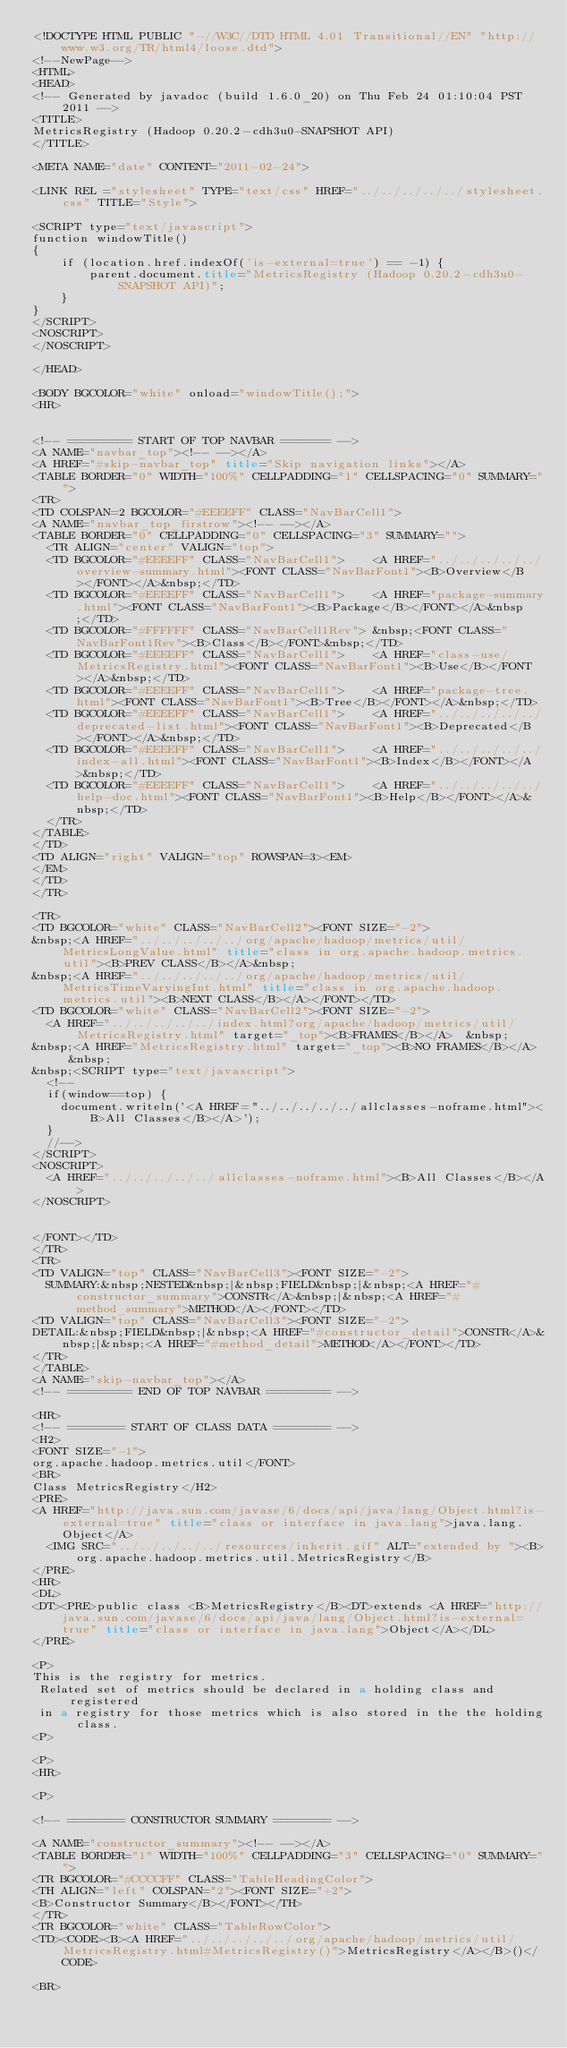<code> <loc_0><loc_0><loc_500><loc_500><_HTML_><!DOCTYPE HTML PUBLIC "-//W3C//DTD HTML 4.01 Transitional//EN" "http://www.w3.org/TR/html4/loose.dtd">
<!--NewPage-->
<HTML>
<HEAD>
<!-- Generated by javadoc (build 1.6.0_20) on Thu Feb 24 01:10:04 PST 2011 -->
<TITLE>
MetricsRegistry (Hadoop 0.20.2-cdh3u0-SNAPSHOT API)
</TITLE>

<META NAME="date" CONTENT="2011-02-24">

<LINK REL ="stylesheet" TYPE="text/css" HREF="../../../../../stylesheet.css" TITLE="Style">

<SCRIPT type="text/javascript">
function windowTitle()
{
    if (location.href.indexOf('is-external=true') == -1) {
        parent.document.title="MetricsRegistry (Hadoop 0.20.2-cdh3u0-SNAPSHOT API)";
    }
}
</SCRIPT>
<NOSCRIPT>
</NOSCRIPT>

</HEAD>

<BODY BGCOLOR="white" onload="windowTitle();">
<HR>


<!-- ========= START OF TOP NAVBAR ======= -->
<A NAME="navbar_top"><!-- --></A>
<A HREF="#skip-navbar_top" title="Skip navigation links"></A>
<TABLE BORDER="0" WIDTH="100%" CELLPADDING="1" CELLSPACING="0" SUMMARY="">
<TR>
<TD COLSPAN=2 BGCOLOR="#EEEEFF" CLASS="NavBarCell1">
<A NAME="navbar_top_firstrow"><!-- --></A>
<TABLE BORDER="0" CELLPADDING="0" CELLSPACING="3" SUMMARY="">
  <TR ALIGN="center" VALIGN="top">
  <TD BGCOLOR="#EEEEFF" CLASS="NavBarCell1">    <A HREF="../../../../../overview-summary.html"><FONT CLASS="NavBarFont1"><B>Overview</B></FONT></A>&nbsp;</TD>
  <TD BGCOLOR="#EEEEFF" CLASS="NavBarCell1">    <A HREF="package-summary.html"><FONT CLASS="NavBarFont1"><B>Package</B></FONT></A>&nbsp;</TD>
  <TD BGCOLOR="#FFFFFF" CLASS="NavBarCell1Rev"> &nbsp;<FONT CLASS="NavBarFont1Rev"><B>Class</B></FONT>&nbsp;</TD>
  <TD BGCOLOR="#EEEEFF" CLASS="NavBarCell1">    <A HREF="class-use/MetricsRegistry.html"><FONT CLASS="NavBarFont1"><B>Use</B></FONT></A>&nbsp;</TD>
  <TD BGCOLOR="#EEEEFF" CLASS="NavBarCell1">    <A HREF="package-tree.html"><FONT CLASS="NavBarFont1"><B>Tree</B></FONT></A>&nbsp;</TD>
  <TD BGCOLOR="#EEEEFF" CLASS="NavBarCell1">    <A HREF="../../../../../deprecated-list.html"><FONT CLASS="NavBarFont1"><B>Deprecated</B></FONT></A>&nbsp;</TD>
  <TD BGCOLOR="#EEEEFF" CLASS="NavBarCell1">    <A HREF="../../../../../index-all.html"><FONT CLASS="NavBarFont1"><B>Index</B></FONT></A>&nbsp;</TD>
  <TD BGCOLOR="#EEEEFF" CLASS="NavBarCell1">    <A HREF="../../../../../help-doc.html"><FONT CLASS="NavBarFont1"><B>Help</B></FONT></A>&nbsp;</TD>
  </TR>
</TABLE>
</TD>
<TD ALIGN="right" VALIGN="top" ROWSPAN=3><EM>
</EM>
</TD>
</TR>

<TR>
<TD BGCOLOR="white" CLASS="NavBarCell2"><FONT SIZE="-2">
&nbsp;<A HREF="../../../../../org/apache/hadoop/metrics/util/MetricsLongValue.html" title="class in org.apache.hadoop.metrics.util"><B>PREV CLASS</B></A>&nbsp;
&nbsp;<A HREF="../../../../../org/apache/hadoop/metrics/util/MetricsTimeVaryingInt.html" title="class in org.apache.hadoop.metrics.util"><B>NEXT CLASS</B></A></FONT></TD>
<TD BGCOLOR="white" CLASS="NavBarCell2"><FONT SIZE="-2">
  <A HREF="../../../../../index.html?org/apache/hadoop/metrics/util/MetricsRegistry.html" target="_top"><B>FRAMES</B></A>  &nbsp;
&nbsp;<A HREF="MetricsRegistry.html" target="_top"><B>NO FRAMES</B></A>  &nbsp;
&nbsp;<SCRIPT type="text/javascript">
  <!--
  if(window==top) {
    document.writeln('<A HREF="../../../../../allclasses-noframe.html"><B>All Classes</B></A>');
  }
  //-->
</SCRIPT>
<NOSCRIPT>
  <A HREF="../../../../../allclasses-noframe.html"><B>All Classes</B></A>
</NOSCRIPT>


</FONT></TD>
</TR>
<TR>
<TD VALIGN="top" CLASS="NavBarCell3"><FONT SIZE="-2">
  SUMMARY:&nbsp;NESTED&nbsp;|&nbsp;FIELD&nbsp;|&nbsp;<A HREF="#constructor_summary">CONSTR</A>&nbsp;|&nbsp;<A HREF="#method_summary">METHOD</A></FONT></TD>
<TD VALIGN="top" CLASS="NavBarCell3"><FONT SIZE="-2">
DETAIL:&nbsp;FIELD&nbsp;|&nbsp;<A HREF="#constructor_detail">CONSTR</A>&nbsp;|&nbsp;<A HREF="#method_detail">METHOD</A></FONT></TD>
</TR>
</TABLE>
<A NAME="skip-navbar_top"></A>
<!-- ========= END OF TOP NAVBAR ========= -->

<HR>
<!-- ======== START OF CLASS DATA ======== -->
<H2>
<FONT SIZE="-1">
org.apache.hadoop.metrics.util</FONT>
<BR>
Class MetricsRegistry</H2>
<PRE>
<A HREF="http://java.sun.com/javase/6/docs/api/java/lang/Object.html?is-external=true" title="class or interface in java.lang">java.lang.Object</A>
  <IMG SRC="../../../../../resources/inherit.gif" ALT="extended by "><B>org.apache.hadoop.metrics.util.MetricsRegistry</B>
</PRE>
<HR>
<DL>
<DT><PRE>public class <B>MetricsRegistry</B><DT>extends <A HREF="http://java.sun.com/javase/6/docs/api/java/lang/Object.html?is-external=true" title="class or interface in java.lang">Object</A></DL>
</PRE>

<P>
This is the registry for metrics.
 Related set of metrics should be declared in a holding class and registered
 in a registry for those metrics which is also stored in the the holding class.
<P>

<P>
<HR>

<P>

<!-- ======== CONSTRUCTOR SUMMARY ======== -->

<A NAME="constructor_summary"><!-- --></A>
<TABLE BORDER="1" WIDTH="100%" CELLPADDING="3" CELLSPACING="0" SUMMARY="">
<TR BGCOLOR="#CCCCFF" CLASS="TableHeadingColor">
<TH ALIGN="left" COLSPAN="2"><FONT SIZE="+2">
<B>Constructor Summary</B></FONT></TH>
</TR>
<TR BGCOLOR="white" CLASS="TableRowColor">
<TD><CODE><B><A HREF="../../../../../org/apache/hadoop/metrics/util/MetricsRegistry.html#MetricsRegistry()">MetricsRegistry</A></B>()</CODE>

<BR></code> 